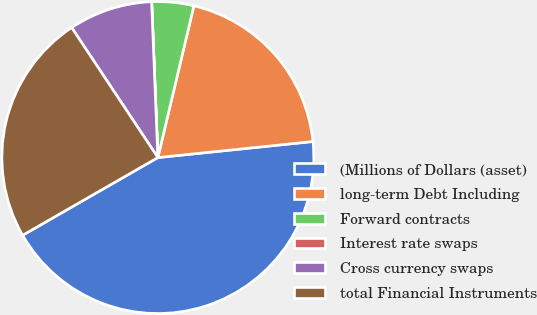Convert chart. <chart><loc_0><loc_0><loc_500><loc_500><pie_chart><fcel>(Millions of Dollars (asset)<fcel>long-term Debt Including<fcel>Forward contracts<fcel>Interest rate swaps<fcel>Cross currency swaps<fcel>total Financial Instruments<nl><fcel>43.34%<fcel>19.65%<fcel>4.34%<fcel>0.01%<fcel>8.68%<fcel>23.98%<nl></chart> 